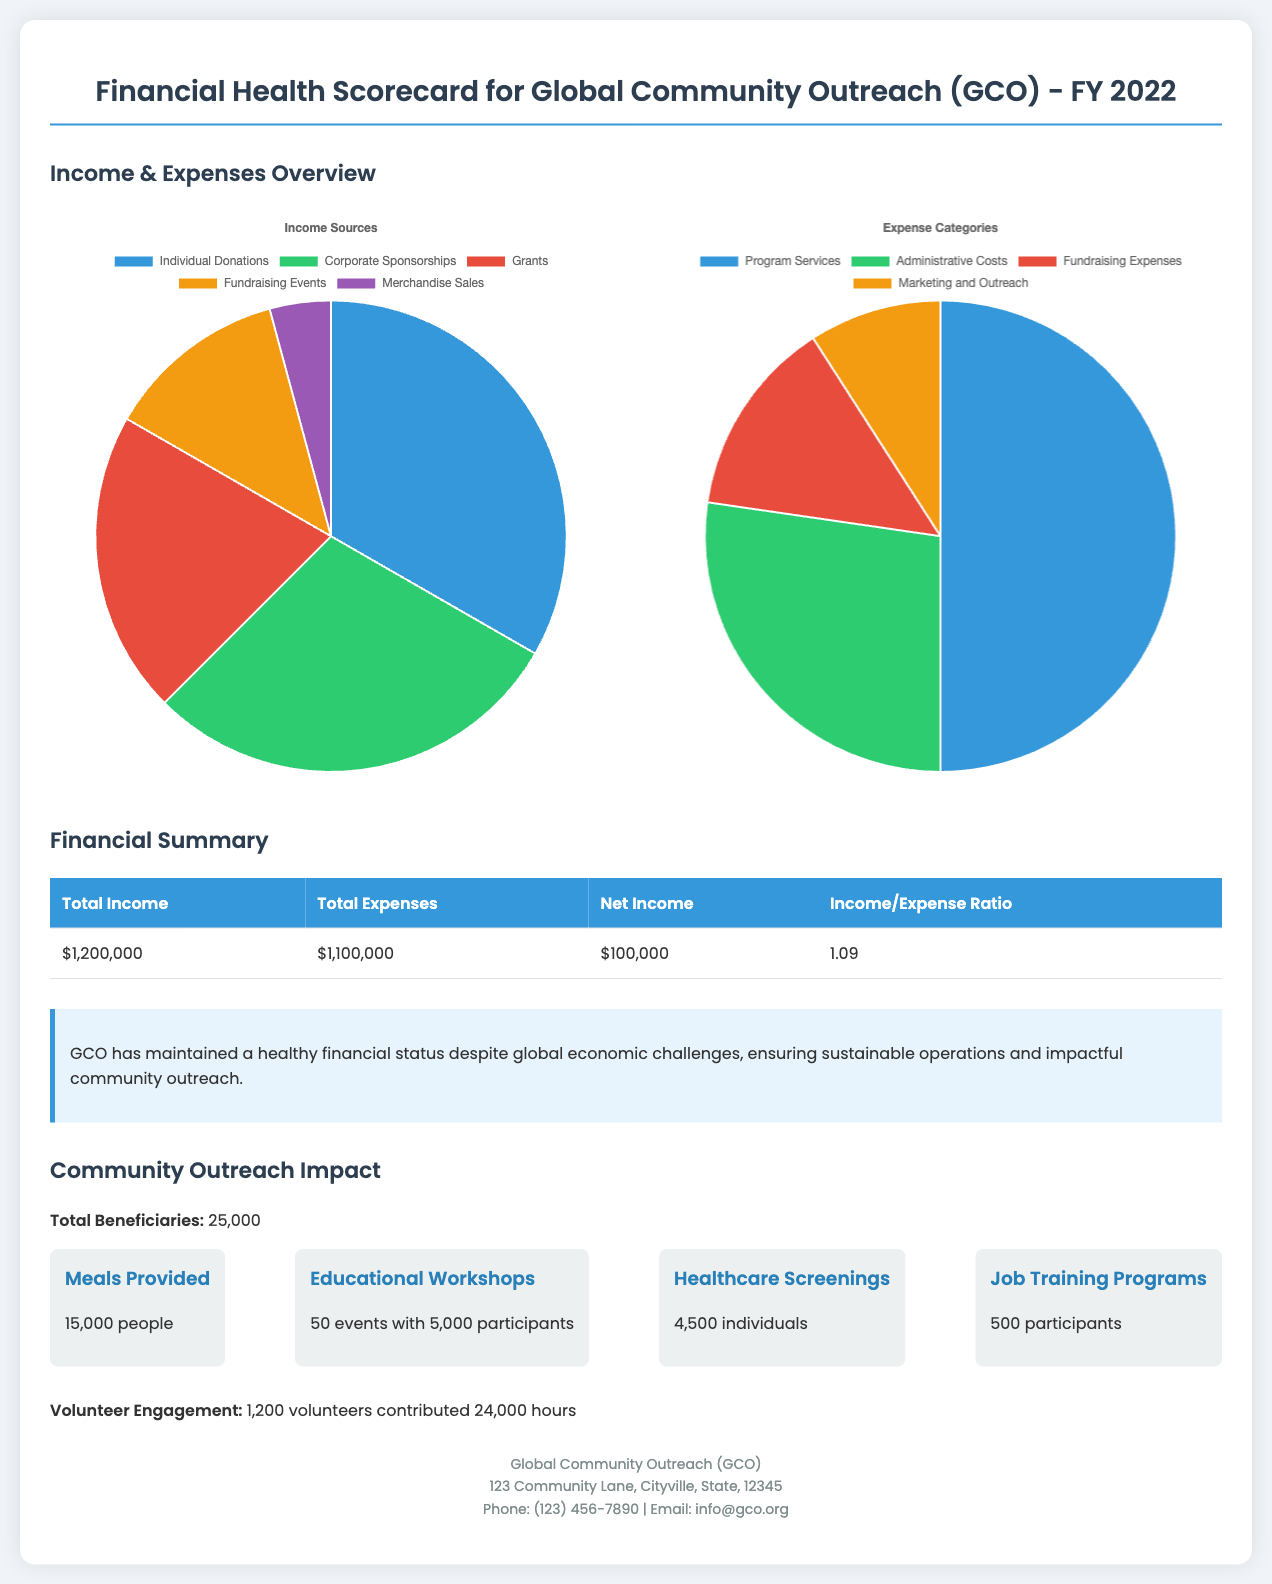What was the total income for FY 2022? The total income is a specific financial figure provided in the detailed financial summary section of the document.
Answer: $1,200,000 What was the total expense for FY 2022? The total expense figure can be found in the financial summary section, detailing the organization's expenditures.
Answer: $1,100,000 What is the net income for FY 2022? The net income represents the difference between total income and total expenses as detailed in the financial summary.
Answer: $100,000 How many educational workshops were conducted? The number of educational workshops is presented in the community outreach impact section, detailing their engagement efforts.
Answer: 50 events What percentage of income comes from individual donations? The breakdown of income sources includes specific percentages, indicating how much comes from individual donations.
Answer: 33.3% What was the income/expense ratio for FY 2022? The income/expense ratio is calculated from the total income and total expenses figures found in the financial summary.
Answer: 1.09 How many total beneficiaries did the organization reach? The total beneficiaries figure is highlighted in the community outreach impact section, revealing the extent of their outreach.
Answer: 25,000 What is the total number of volunteers engaged? The total number of volunteers is specifically stated in the community outreach impact section, showcasing community involvement.
Answer: 1,200 volunteers What is the value of healthcare screenings provided? The value pertains to the impact of healthcare screenings listed under community outreach impact, emphasizing health services provided.
Answer: 4,500 individuals 